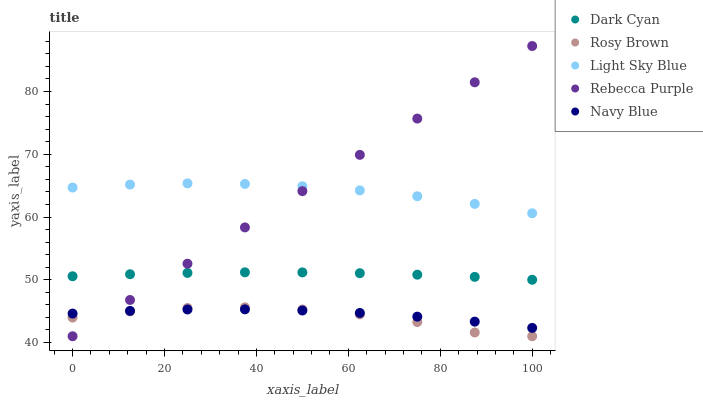Does Rosy Brown have the minimum area under the curve?
Answer yes or no. Yes. Does Rebecca Purple have the maximum area under the curve?
Answer yes or no. Yes. Does Navy Blue have the minimum area under the curve?
Answer yes or no. No. Does Navy Blue have the maximum area under the curve?
Answer yes or no. No. Is Rebecca Purple the smoothest?
Answer yes or no. Yes. Is Rosy Brown the roughest?
Answer yes or no. Yes. Is Navy Blue the smoothest?
Answer yes or no. No. Is Navy Blue the roughest?
Answer yes or no. No. Does Rosy Brown have the lowest value?
Answer yes or no. Yes. Does Navy Blue have the lowest value?
Answer yes or no. No. Does Rebecca Purple have the highest value?
Answer yes or no. Yes. Does Rosy Brown have the highest value?
Answer yes or no. No. Is Navy Blue less than Dark Cyan?
Answer yes or no. Yes. Is Light Sky Blue greater than Dark Cyan?
Answer yes or no. Yes. Does Navy Blue intersect Rebecca Purple?
Answer yes or no. Yes. Is Navy Blue less than Rebecca Purple?
Answer yes or no. No. Is Navy Blue greater than Rebecca Purple?
Answer yes or no. No. Does Navy Blue intersect Dark Cyan?
Answer yes or no. No. 